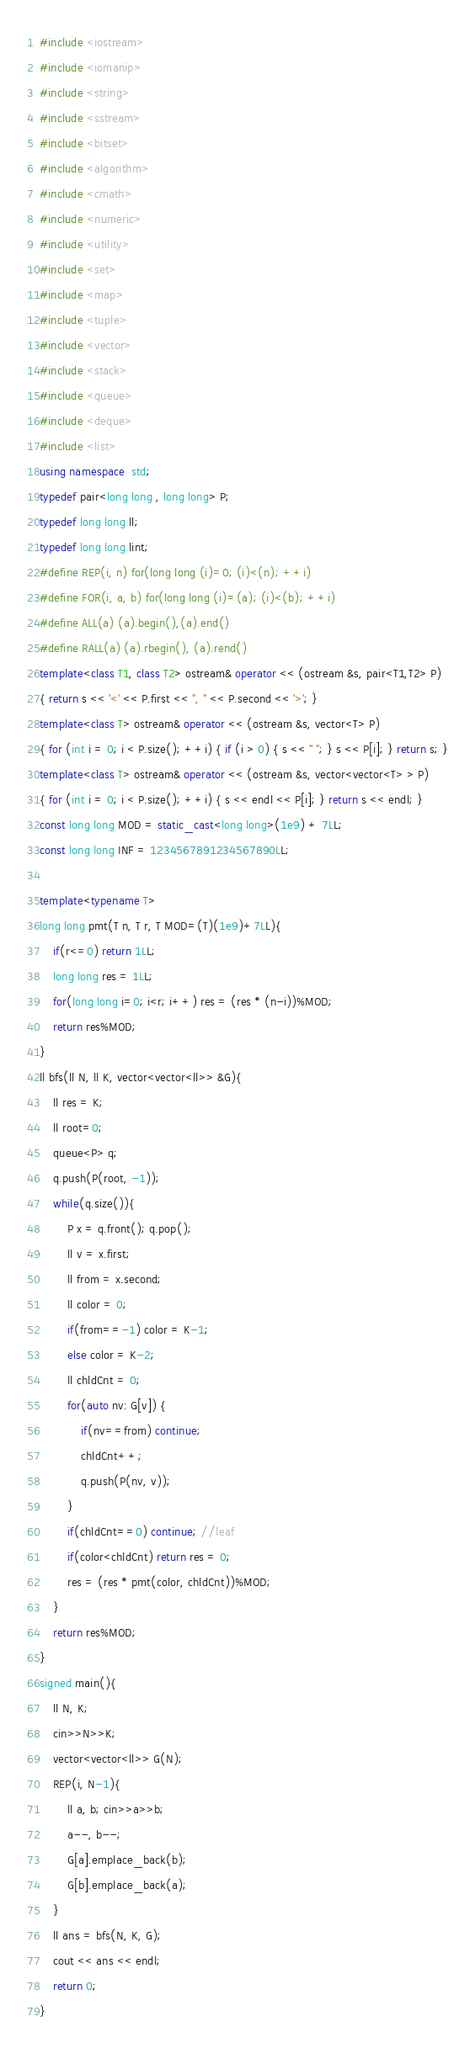Convert code to text. <code><loc_0><loc_0><loc_500><loc_500><_C++_>#include <iostream>
#include <iomanip>
#include <string>
#include <sstream>
#include <bitset>
#include <algorithm>
#include <cmath>
#include <numeric>
#include <utility>
#include <set>
#include <map>
#include <tuple> 
#include <vector>
#include <stack>
#include <queue>
#include <deque>
#include <list>
using namespace  std;
typedef pair<long long , long long> P;
typedef long long ll;
typedef long long lint;
#define REP(i, n) for(long long (i)=0; (i)<(n); ++i)
#define FOR(i, a, b) for(long long (i)=(a); (i)<(b); ++i)
#define ALL(a) (a).begin(),(a).end()
#define RALL(a) (a).rbegin(), (a).rend()
template<class T1, class T2> ostream& operator << (ostream &s, pair<T1,T2> P)
{ return s << '<' << P.first << ", " << P.second << '>'; }
template<class T> ostream& operator << (ostream &s, vector<T> P)
{ for (int i = 0; i < P.size(); ++i) { if (i > 0) { s << " "; } s << P[i]; } return s; }
template<class T> ostream& operator << (ostream &s, vector<vector<T> > P)
{ for (int i = 0; i < P.size(); ++i) { s << endl << P[i]; } return s << endl; }
const long long MOD = static_cast<long long>(1e9) + 7LL;
const long long INF = 1234567891234567890LL;

template<typename T>
long long pmt(T n, T r, T MOD=(T)(1e9)+7LL){
    if(r<=0) return 1LL;
    long long res = 1LL;
    for(long long i=0; i<r; i++) res = (res * (n-i))%MOD;
    return res%MOD;
}
ll bfs(ll N, ll K, vector<vector<ll>> &G){
    ll res = K;
    ll root=0;
    queue<P> q;
    q.push(P(root, -1));
    while(q.size()){
        P x = q.front(); q.pop();
        ll v = x.first;
        ll from = x.second;
        ll color = 0;
        if(from==-1) color = K-1;
        else color = K-2;
        ll chldCnt = 0;
        for(auto nv: G[v]) {
            if(nv==from) continue;
            chldCnt++;
            q.push(P(nv, v));
        }
        if(chldCnt==0) continue; //leaf 
        if(color<chldCnt) return res = 0;  
        res = (res * pmt(color, chldCnt))%MOD;
    }
    return res%MOD;
}
signed main(){
    ll N, K;
    cin>>N>>K;
    vector<vector<ll>> G(N);
    REP(i, N-1){
        ll a, b; cin>>a>>b;
        a--, b--;
        G[a].emplace_back(b);
        G[b].emplace_back(a);
    } 
    ll ans = bfs(N, K, G);
    cout << ans << endl;
    return 0;
}</code> 